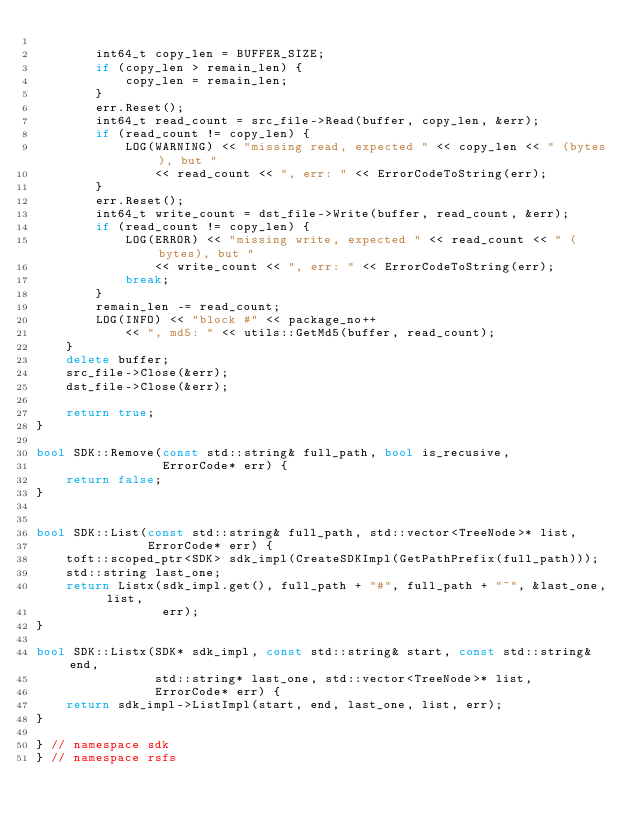<code> <loc_0><loc_0><loc_500><loc_500><_C++_>
        int64_t copy_len = BUFFER_SIZE;
        if (copy_len > remain_len) {
            copy_len = remain_len;
        }
        err.Reset();
        int64_t read_count = src_file->Read(buffer, copy_len, &err);
        if (read_count != copy_len) {
            LOG(WARNING) << "missing read, expected " << copy_len << " (bytes), but "
                << read_count << ", err: " << ErrorCodeToString(err);
        }
        err.Reset();
        int64_t write_count = dst_file->Write(buffer, read_count, &err);
        if (read_count != copy_len) {
            LOG(ERROR) << "missing write, expected " << read_count << " (bytes), but "
                << write_count << ", err: " << ErrorCodeToString(err);
            break;
        }
        remain_len -= read_count;
        LOG(INFO) << "block #" << package_no++
            << ", md5: " << utils::GetMd5(buffer, read_count);
    }
    delete buffer;
    src_file->Close(&err);
    dst_file->Close(&err);

    return true;
}

bool SDK::Remove(const std::string& full_path, bool is_recusive,
                 ErrorCode* err) {
    return false;
}


bool SDK::List(const std::string& full_path, std::vector<TreeNode>* list,
               ErrorCode* err) {
    toft::scoped_ptr<SDK> sdk_impl(CreateSDKImpl(GetPathPrefix(full_path)));
    std::string last_one;
    return Listx(sdk_impl.get(), full_path + "#", full_path + "~", &last_one, list,
                 err);
}

bool SDK::Listx(SDK* sdk_impl, const std::string& start, const std::string& end,
                std::string* last_one, std::vector<TreeNode>* list,
                ErrorCode* err) {
    return sdk_impl->ListImpl(start, end, last_one, list, err);
}

} // namespace sdk
} // namespace rsfs
</code> 